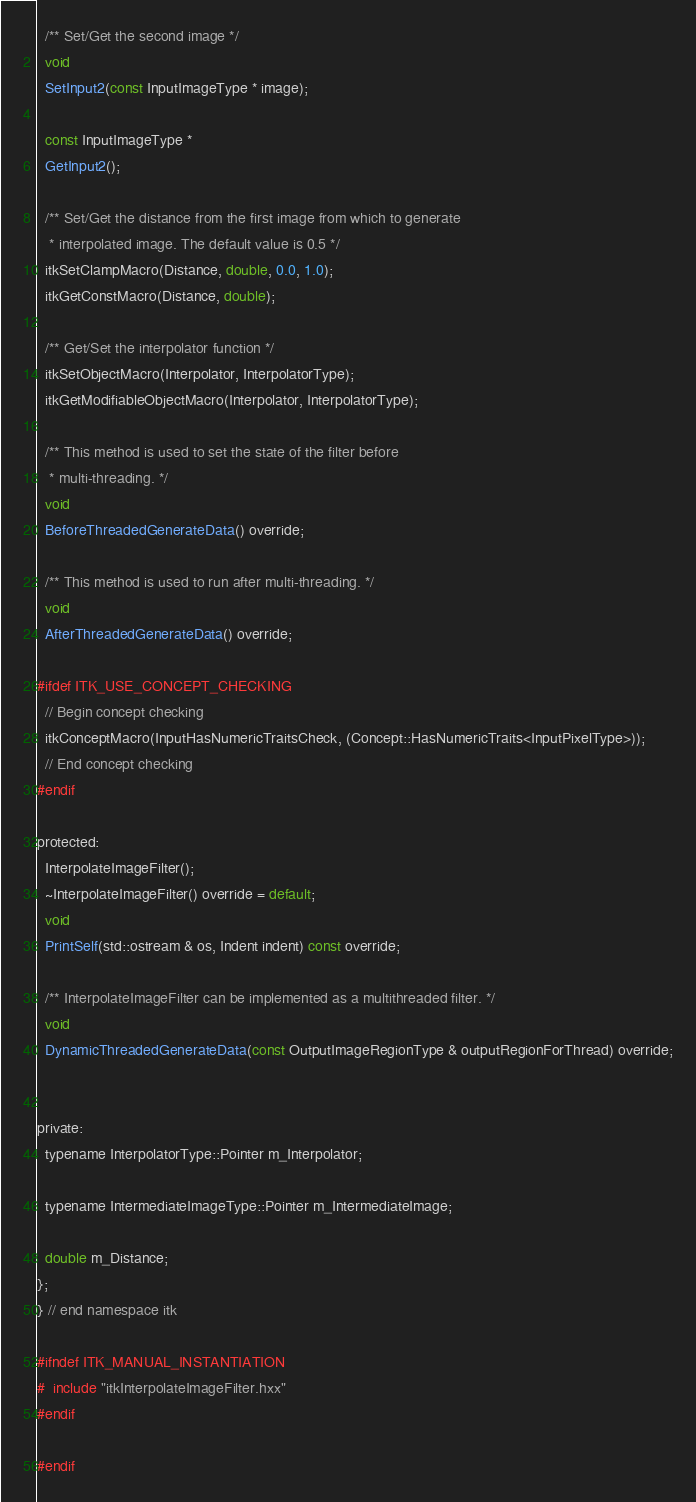<code> <loc_0><loc_0><loc_500><loc_500><_C_>
  /** Set/Get the second image */
  void
  SetInput2(const InputImageType * image);

  const InputImageType *
  GetInput2();

  /** Set/Get the distance from the first image from which to generate
   * interpolated image. The default value is 0.5 */
  itkSetClampMacro(Distance, double, 0.0, 1.0);
  itkGetConstMacro(Distance, double);

  /** Get/Set the interpolator function */
  itkSetObjectMacro(Interpolator, InterpolatorType);
  itkGetModifiableObjectMacro(Interpolator, InterpolatorType);

  /** This method is used to set the state of the filter before
   * multi-threading. */
  void
  BeforeThreadedGenerateData() override;

  /** This method is used to run after multi-threading. */
  void
  AfterThreadedGenerateData() override;

#ifdef ITK_USE_CONCEPT_CHECKING
  // Begin concept checking
  itkConceptMacro(InputHasNumericTraitsCheck, (Concept::HasNumericTraits<InputPixelType>));
  // End concept checking
#endif

protected:
  InterpolateImageFilter();
  ~InterpolateImageFilter() override = default;
  void
  PrintSelf(std::ostream & os, Indent indent) const override;

  /** InterpolateImageFilter can be implemented as a multithreaded filter. */
  void
  DynamicThreadedGenerateData(const OutputImageRegionType & outputRegionForThread) override;


private:
  typename InterpolatorType::Pointer m_Interpolator;

  typename IntermediateImageType::Pointer m_IntermediateImage;

  double m_Distance;
};
} // end namespace itk

#ifndef ITK_MANUAL_INSTANTIATION
#  include "itkInterpolateImageFilter.hxx"
#endif

#endif
</code> 